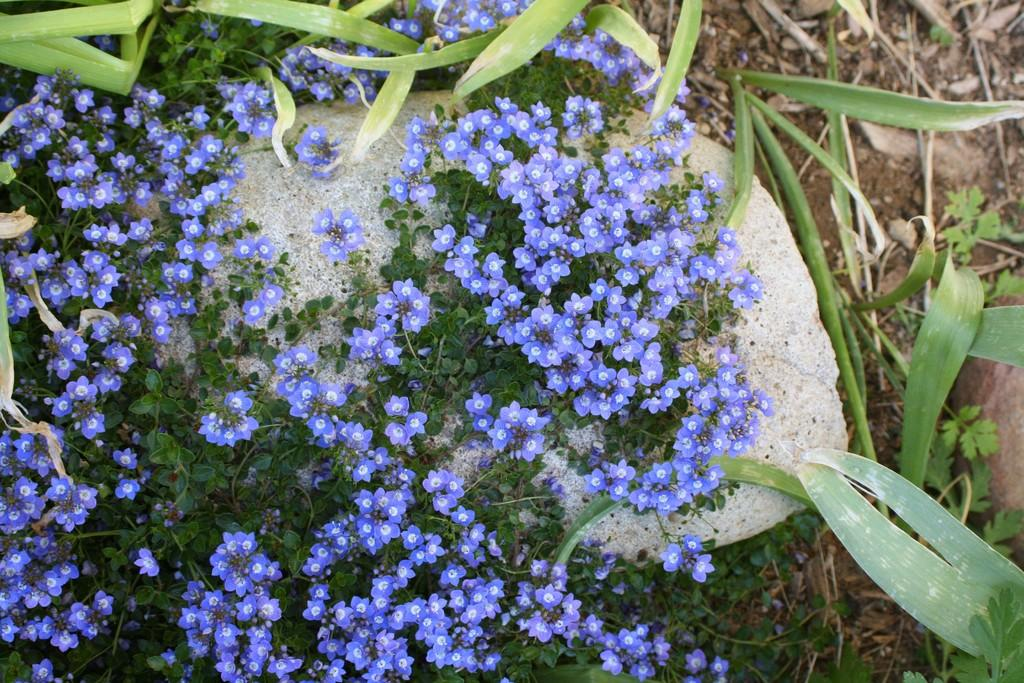What type of plant is visible in the image? There is a plant with a bunch of flowers in the image. What other object can be seen in the image? There is a stone in the image. What type of drum is being played in the background of the image? There is no drum present in the image; it only features a plant with a bunch of flowers and a stone. 